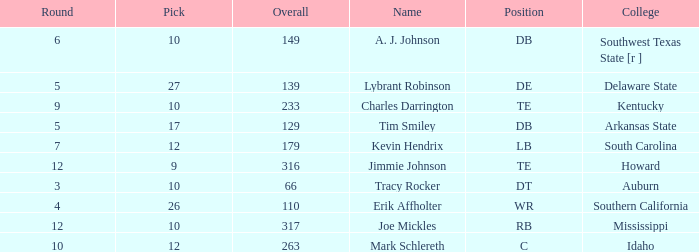What is the average Pick, when Name is "Lybrant Robinson", and when Overall is less than 139? None. 